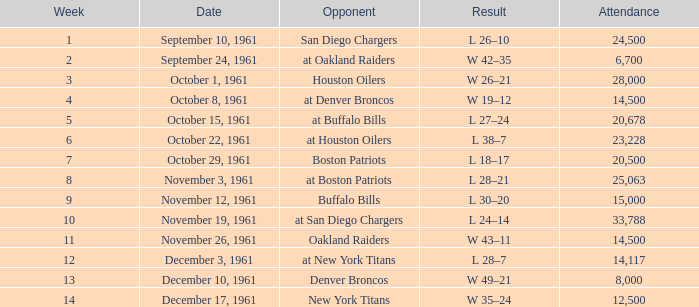What is the top attendance for weeks past 2 on october 29, 1961? 20500.0. 